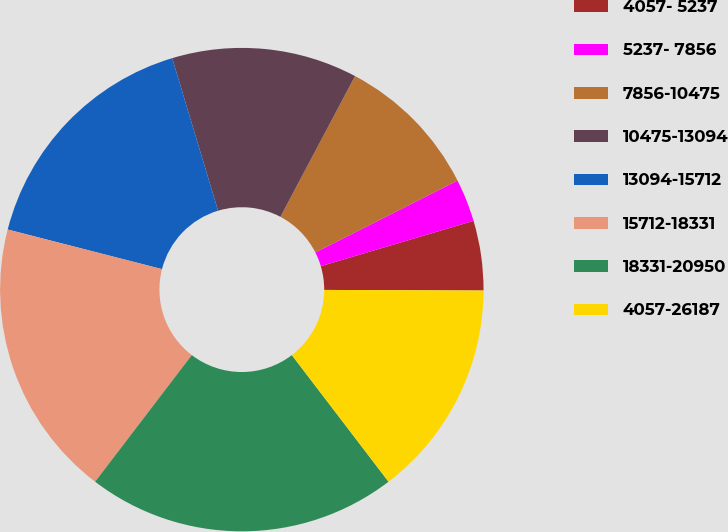Convert chart. <chart><loc_0><loc_0><loc_500><loc_500><pie_chart><fcel>4057- 5237<fcel>5237- 7856<fcel>7856-10475<fcel>10475-13094<fcel>13094-15712<fcel>15712-18331<fcel>18331-20950<fcel>4057-26187<nl><fcel>4.65%<fcel>2.86%<fcel>9.79%<fcel>12.41%<fcel>16.35%<fcel>18.62%<fcel>20.76%<fcel>14.56%<nl></chart> 